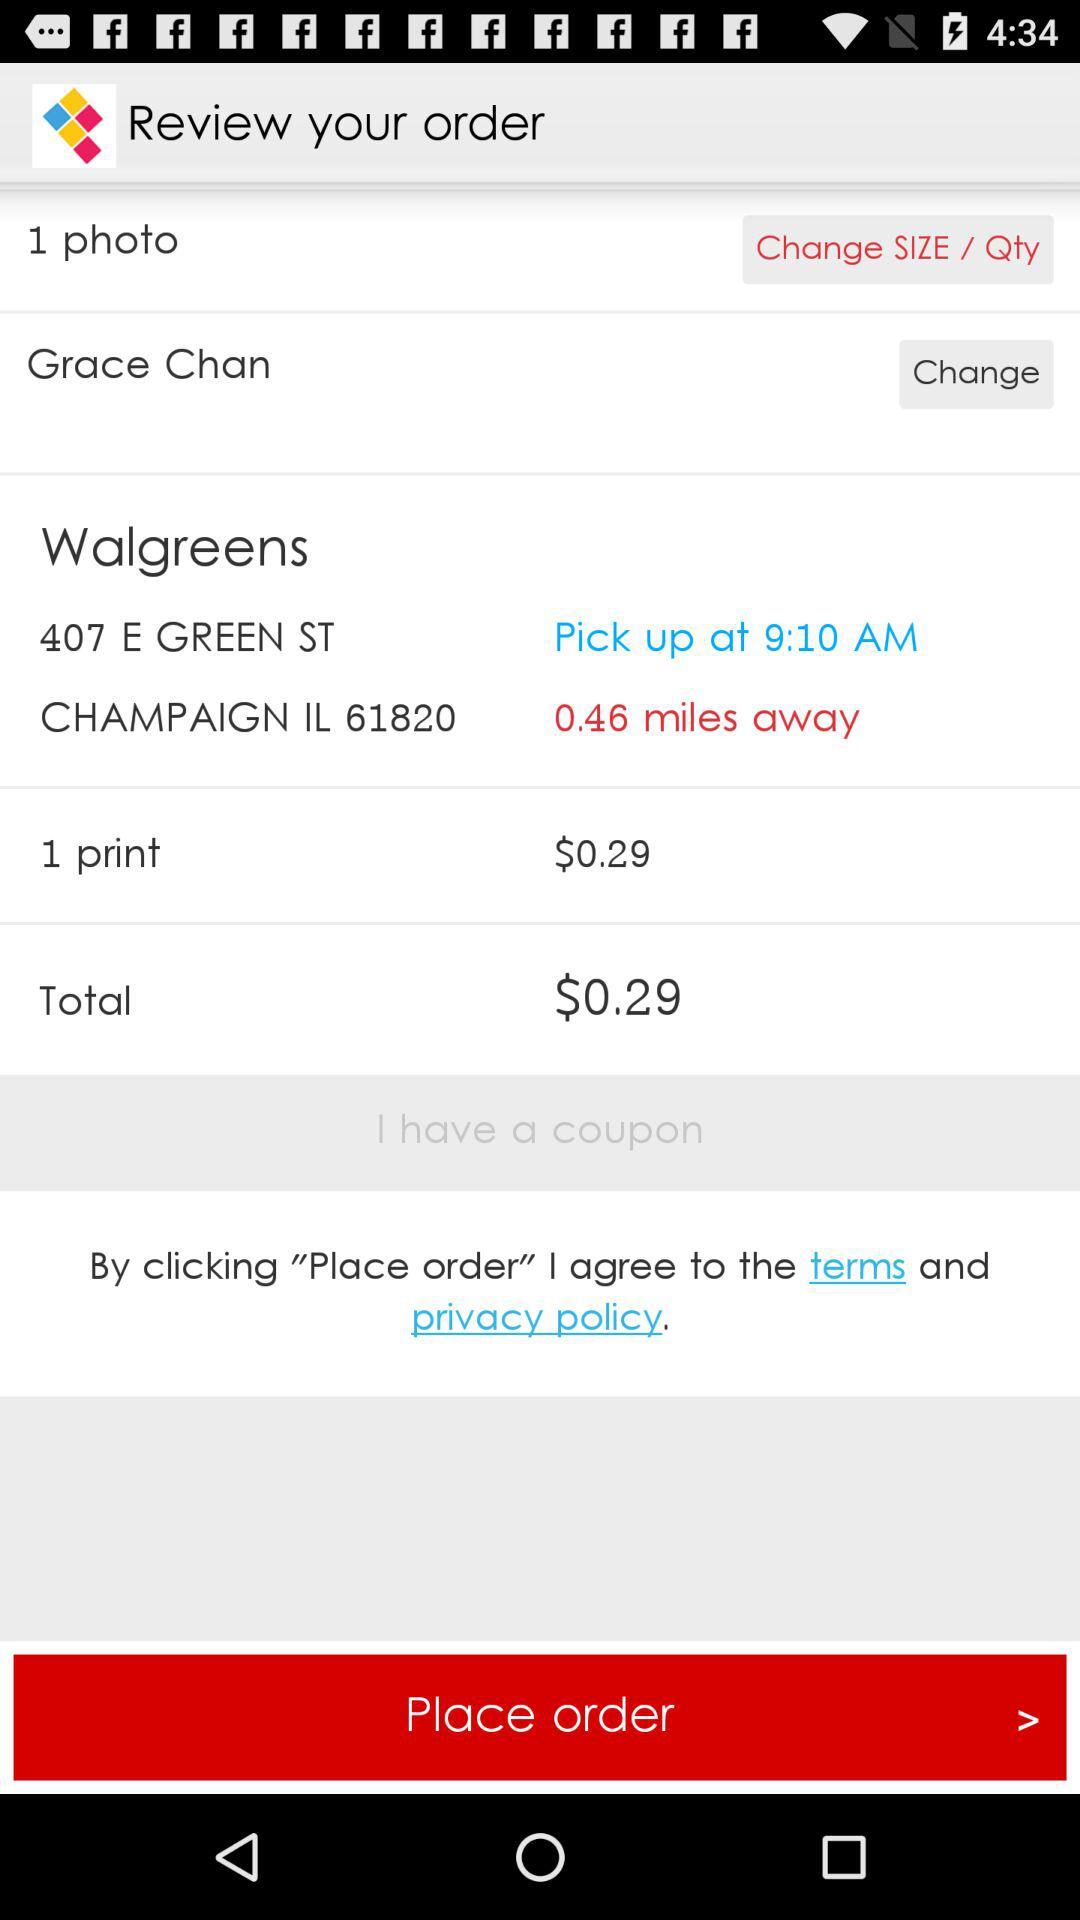How many miles away is the Walgreens location?
Answer the question using a single word or phrase. 0.46 miles 